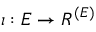Convert formula to latex. <formula><loc_0><loc_0><loc_500><loc_500>\iota \colon E \to R ^ { ( E ) }</formula> 